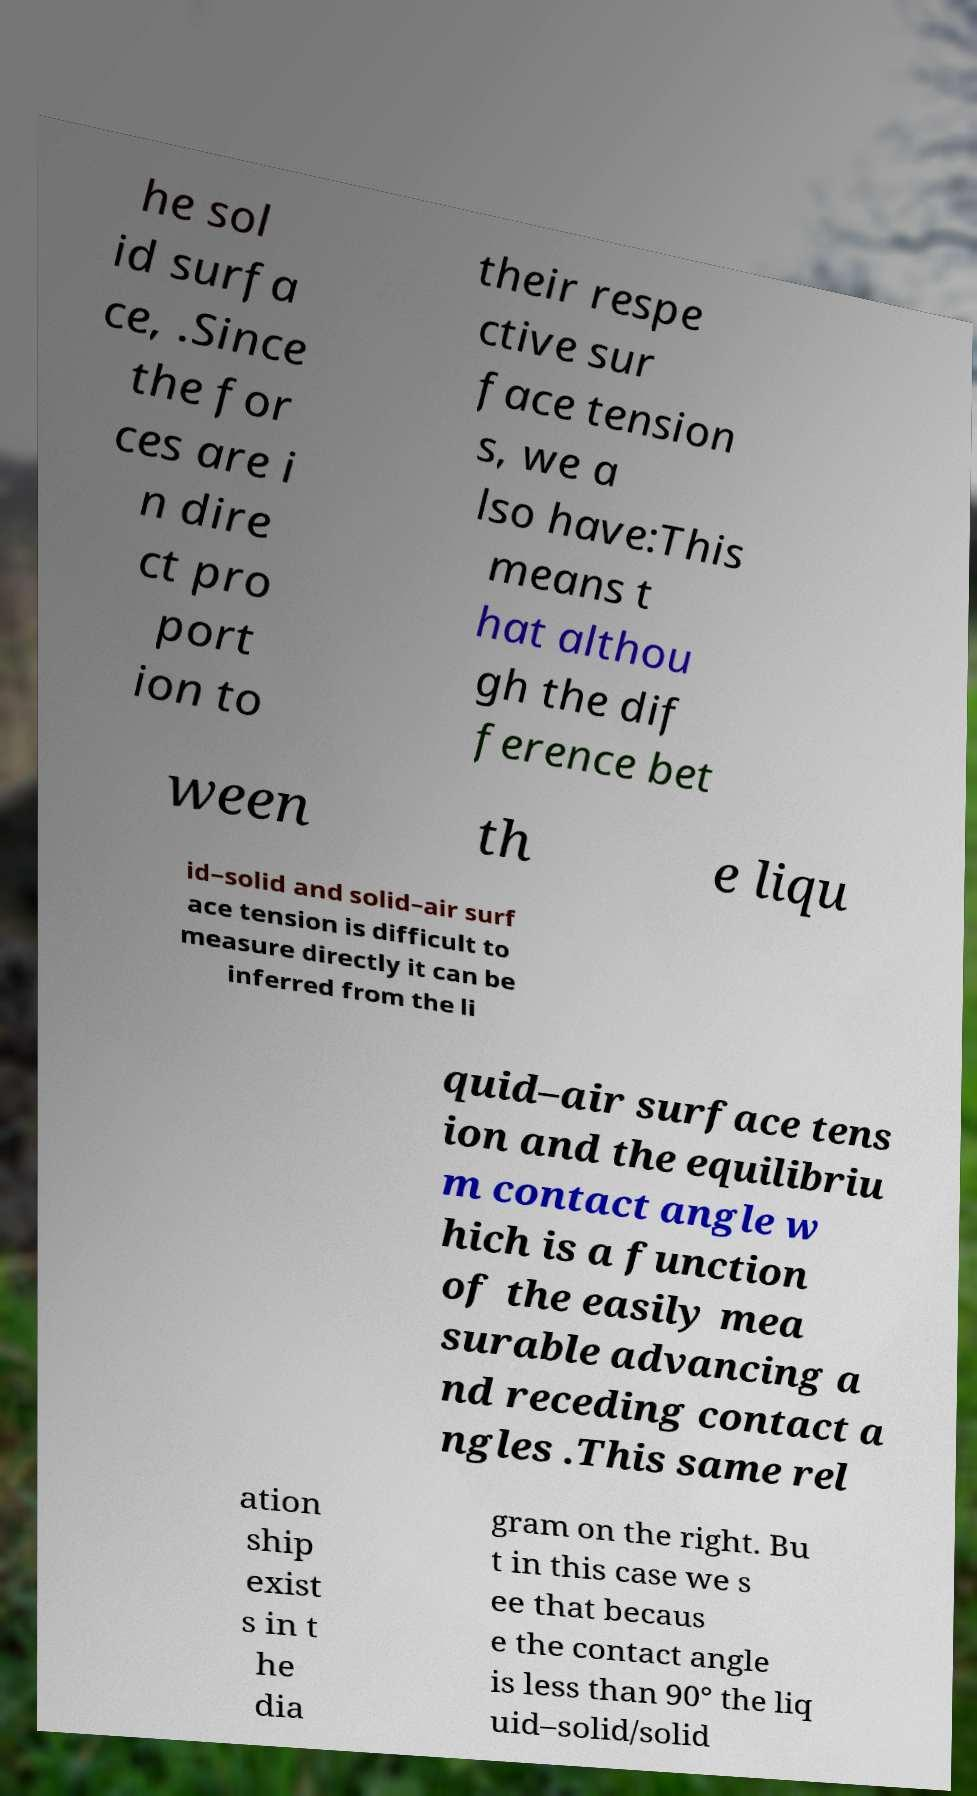Please read and relay the text visible in this image. What does it say? he sol id surfa ce, .Since the for ces are i n dire ct pro port ion to their respe ctive sur face tension s, we a lso have:This means t hat althou gh the dif ference bet ween th e liqu id–solid and solid–air surf ace tension is difficult to measure directly it can be inferred from the li quid–air surface tens ion and the equilibriu m contact angle w hich is a function of the easily mea surable advancing a nd receding contact a ngles .This same rel ation ship exist s in t he dia gram on the right. Bu t in this case we s ee that becaus e the contact angle is less than 90° the liq uid–solid/solid 